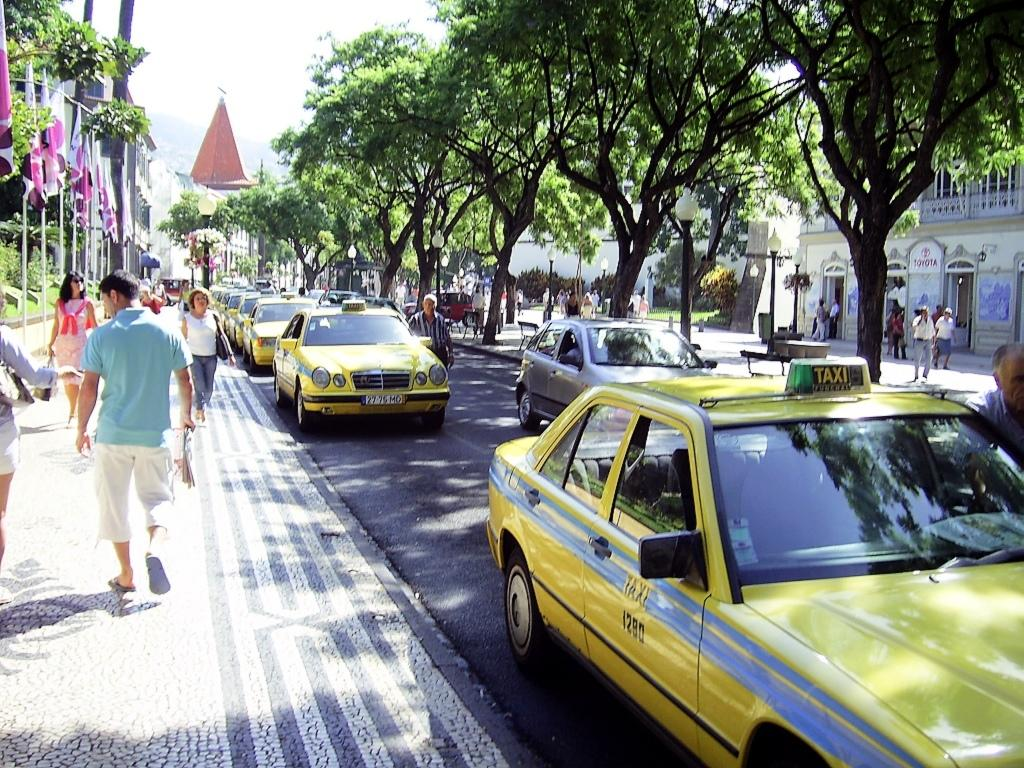<image>
Provide a brief description of the given image. A line of yellow taxi cabs are on a street, and the one in the front is taxi number 1290. 